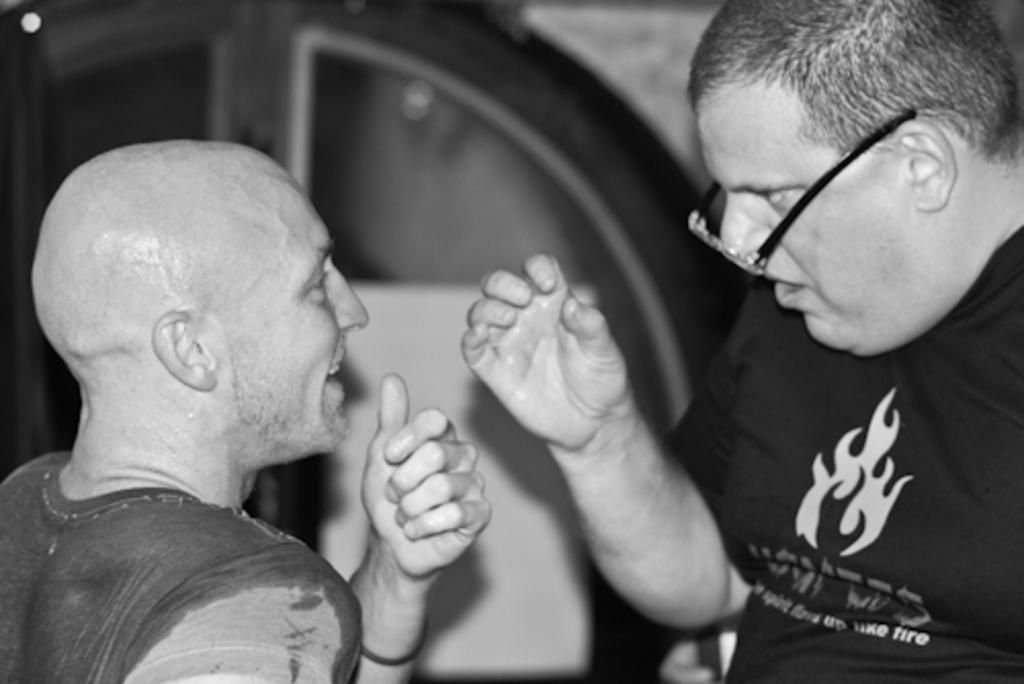Could you give a brief overview of what you see in this image? In this picture there is a bald man who is wearing t-shirt. In front of him there is a man who is wearing spectacle and black t-shirt. In the back there is a door. 